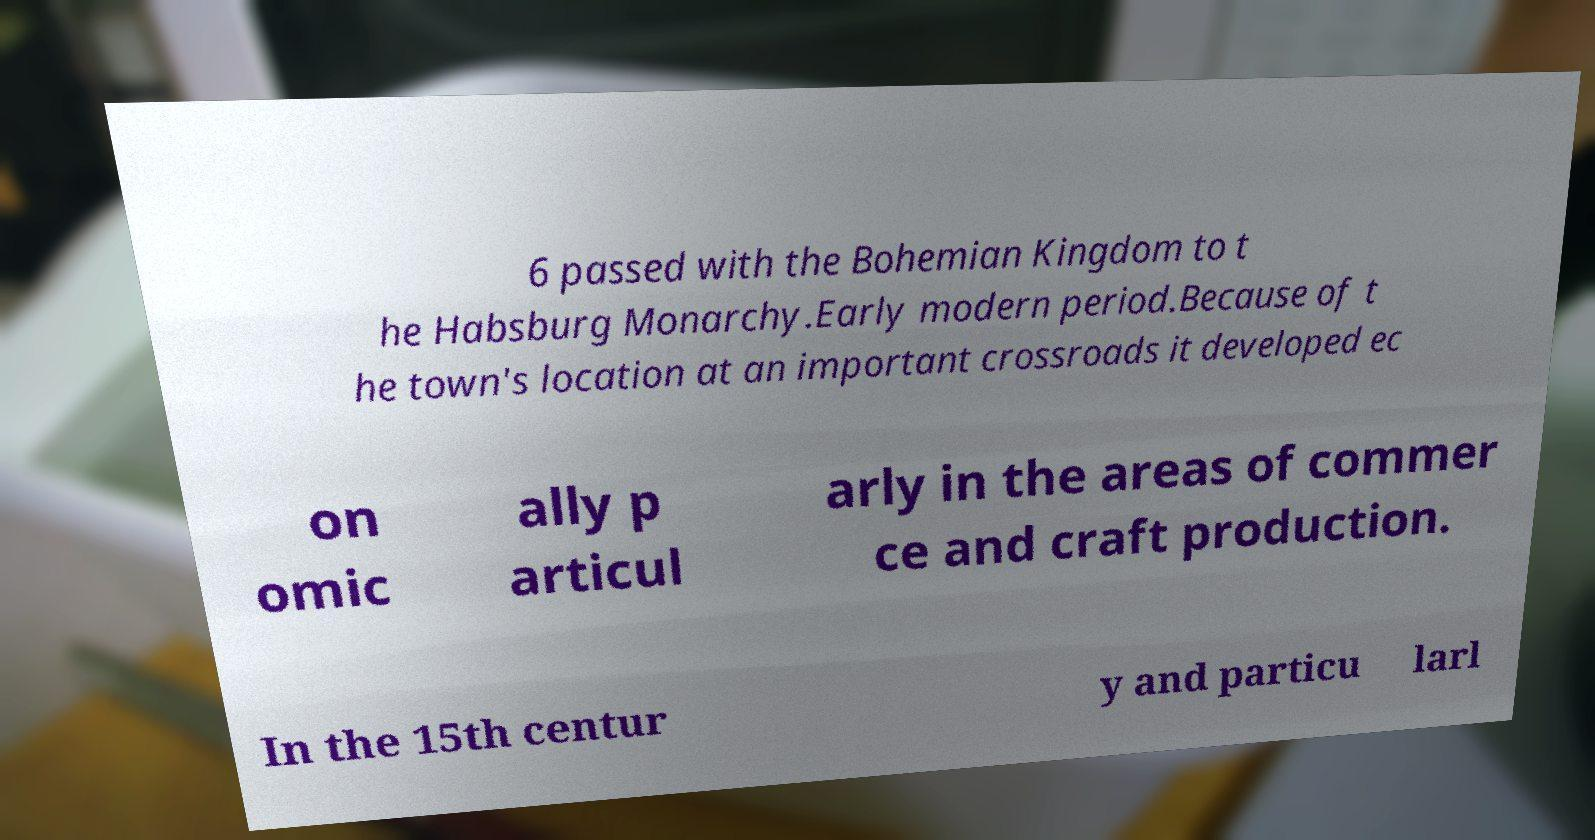For documentation purposes, I need the text within this image transcribed. Could you provide that? 6 passed with the Bohemian Kingdom to t he Habsburg Monarchy.Early modern period.Because of t he town's location at an important crossroads it developed ec on omic ally p articul arly in the areas of commer ce and craft production. In the 15th centur y and particu larl 